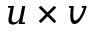<formula> <loc_0><loc_0><loc_500><loc_500>u \times v</formula> 